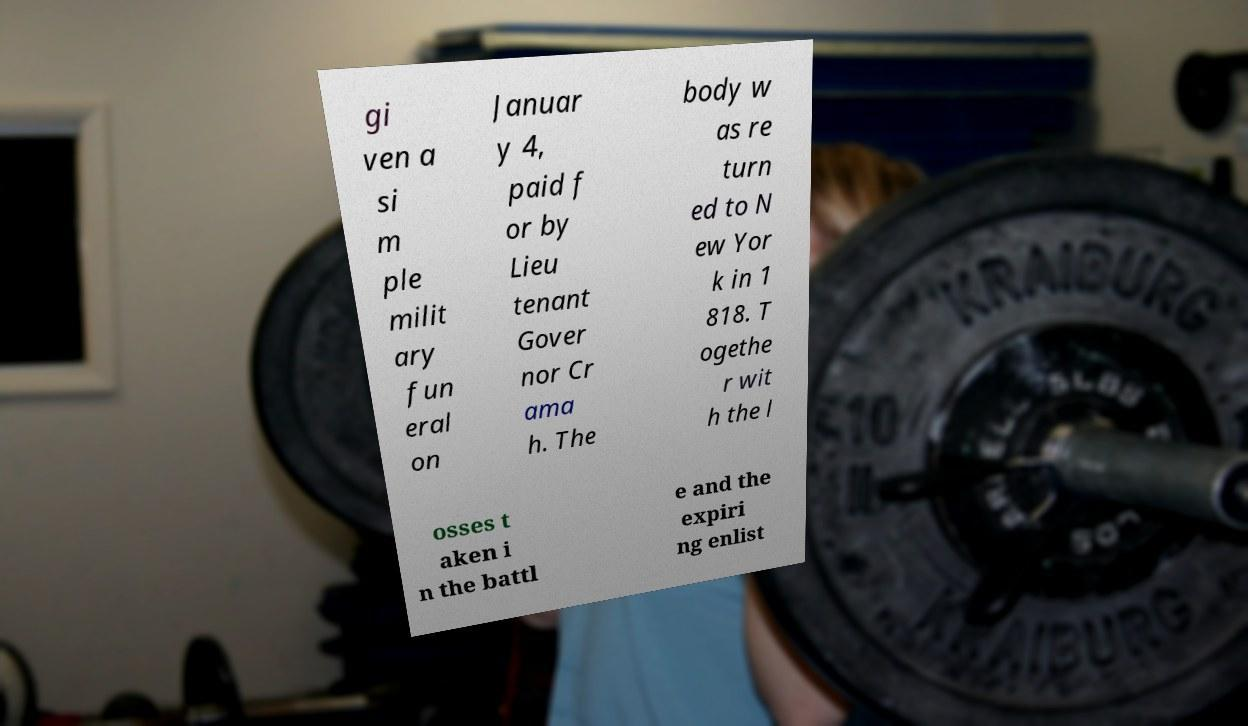What messages or text are displayed in this image? I need them in a readable, typed format. gi ven a si m ple milit ary fun eral on Januar y 4, paid f or by Lieu tenant Gover nor Cr ama h. The body w as re turn ed to N ew Yor k in 1 818. T ogethe r wit h the l osses t aken i n the battl e and the expiri ng enlist 